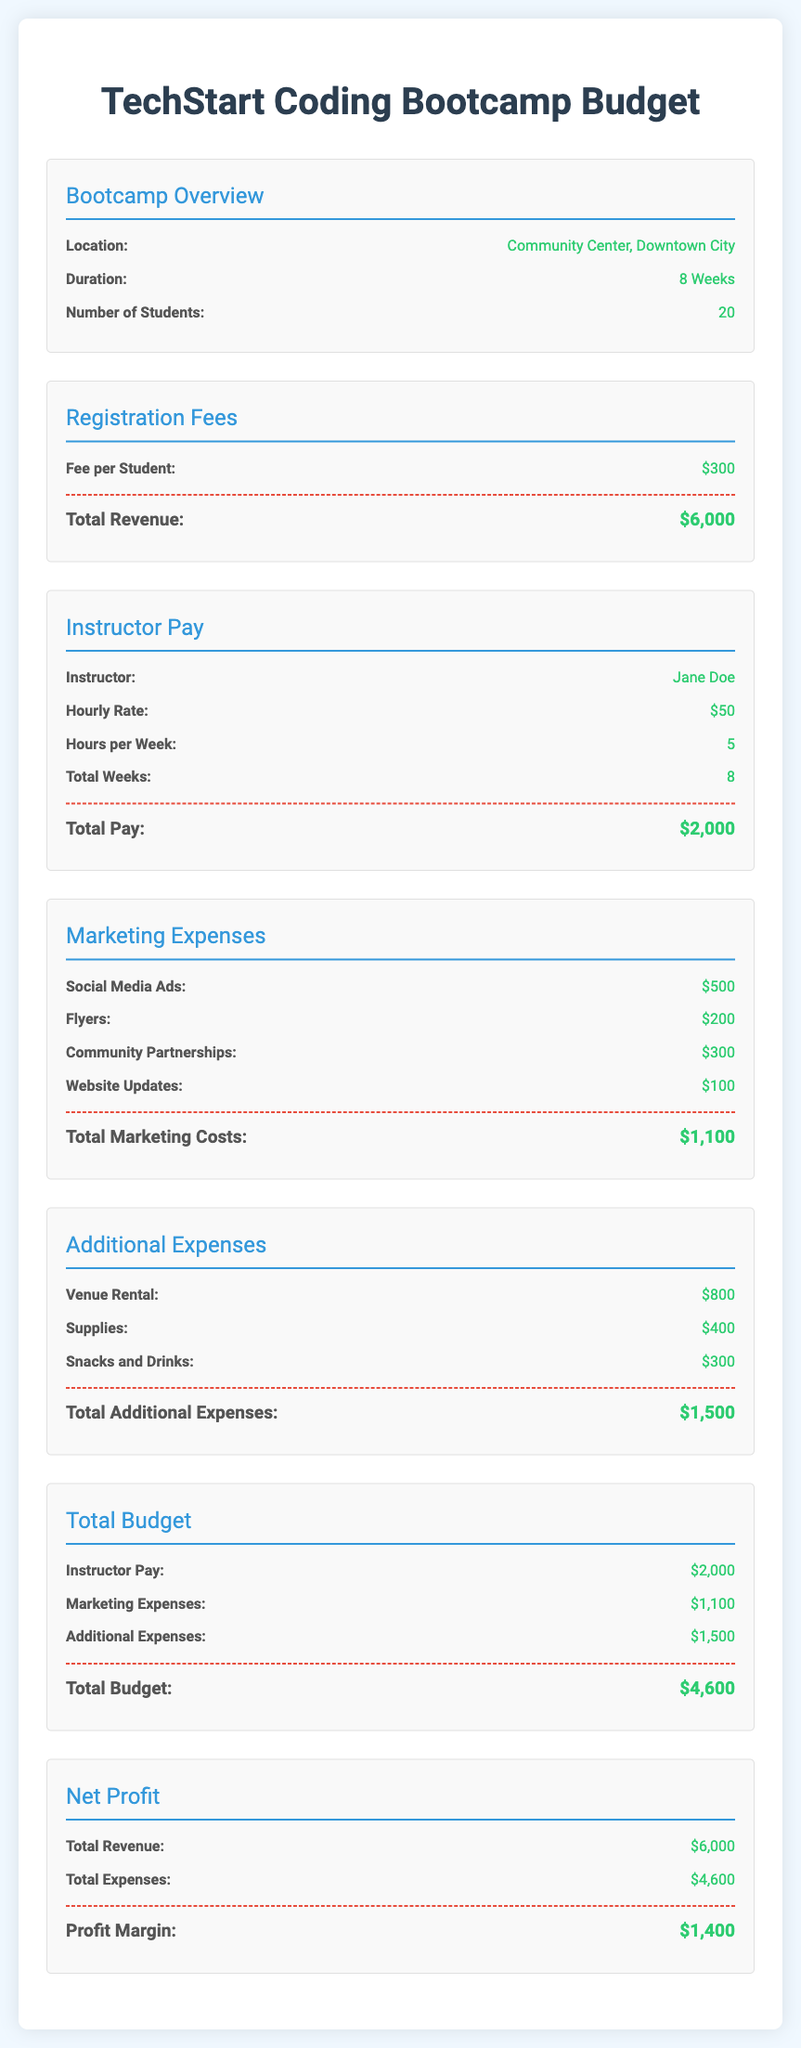What is the location of the bootcamp? The location is specified in the overview section, indicating where the event takes place.
Answer: Community Center, Downtown City What is the fee per student? The fee is detailed under the Registration Fees section, showing the cost required for registration.
Answer: $300 How many weeks does the bootcamp last? The duration of the bootcamp is indicated in the overview, stating how long the program runs.
Answer: 8 Weeks What is the total pay for the instructor? The total pay is calculated in the Instructor Pay section, summarizing the amount that will be paid to the instructor.
Answer: $2,000 What are the total marketing costs? The total marketing costs are summarized in the Marketing Expenses section, which lists the combined expenses for marketing activities.
Answer: $1,100 What is the number of students enrolled? The number of students is specified in the overview section, indicating how many participants are expected.
Answer: 20 What is the total revenue generated? The total revenue is mentioned under Registration Fees, representing the sum from all student fees collected.
Answer: $6,000 What is the total budget for the bootcamp? The total budget is presented in the Total Budget section, summarizing all expenses related to the bootcamp.
Answer: $4,600 What is the profit margin? The profit margin is derived from the Net Profit section, depicting the difference between revenue and total expenses.
Answer: $1,400 